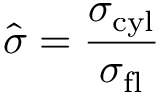<formula> <loc_0><loc_0><loc_500><loc_500>\hat { \sigma } = { \frac { \sigma _ { c y l } } { \sigma _ { f l } } }</formula> 